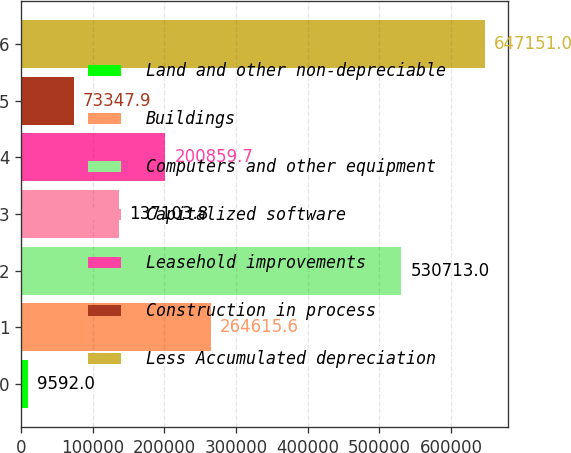Convert chart to OTSL. <chart><loc_0><loc_0><loc_500><loc_500><bar_chart><fcel>Land and other non-depreciable<fcel>Buildings<fcel>Computers and other equipment<fcel>Capitalized software<fcel>Leasehold improvements<fcel>Construction in process<fcel>Less Accumulated depreciation<nl><fcel>9592<fcel>264616<fcel>530713<fcel>137104<fcel>200860<fcel>73347.9<fcel>647151<nl></chart> 